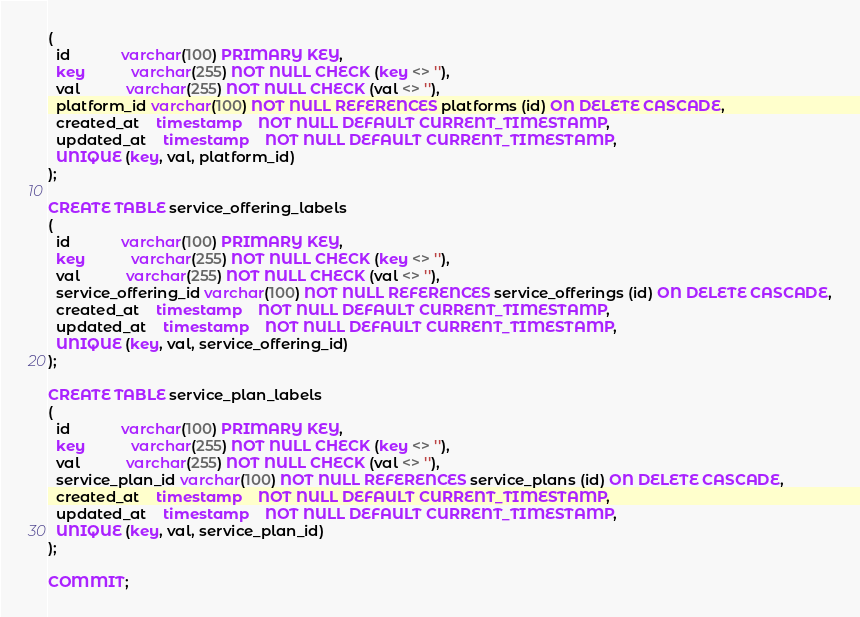<code> <loc_0><loc_0><loc_500><loc_500><_SQL_>(
  id            varchar(100) PRIMARY KEY,
  key           varchar(255) NOT NULL CHECK (key <> ''),
  val           varchar(255) NOT NULL CHECK (val <> ''),
  platform_id varchar(100) NOT NULL REFERENCES platforms (id) ON DELETE CASCADE,
  created_at    timestamp    NOT NULL DEFAULT CURRENT_TIMESTAMP,
  updated_at    timestamp    NOT NULL DEFAULT CURRENT_TIMESTAMP,
  UNIQUE (key, val, platform_id)
);

CREATE TABLE service_offering_labels
(
  id            varchar(100) PRIMARY KEY,
  key           varchar(255) NOT NULL CHECK (key <> ''),
  val           varchar(255) NOT NULL CHECK (val <> ''),
  service_offering_id varchar(100) NOT NULL REFERENCES service_offerings (id) ON DELETE CASCADE,
  created_at    timestamp    NOT NULL DEFAULT CURRENT_TIMESTAMP,
  updated_at    timestamp    NOT NULL DEFAULT CURRENT_TIMESTAMP,
  UNIQUE (key, val, service_offering_id)
);

CREATE TABLE service_plan_labels
(
  id            varchar(100) PRIMARY KEY,
  key           varchar(255) NOT NULL CHECK (key <> ''),
  val           varchar(255) NOT NULL CHECK (val <> ''),
  service_plan_id varchar(100) NOT NULL REFERENCES service_plans (id) ON DELETE CASCADE,
  created_at    timestamp    NOT NULL DEFAULT CURRENT_TIMESTAMP,
  updated_at    timestamp    NOT NULL DEFAULT CURRENT_TIMESTAMP,
  UNIQUE (key, val, service_plan_id)
);

COMMIT;</code> 